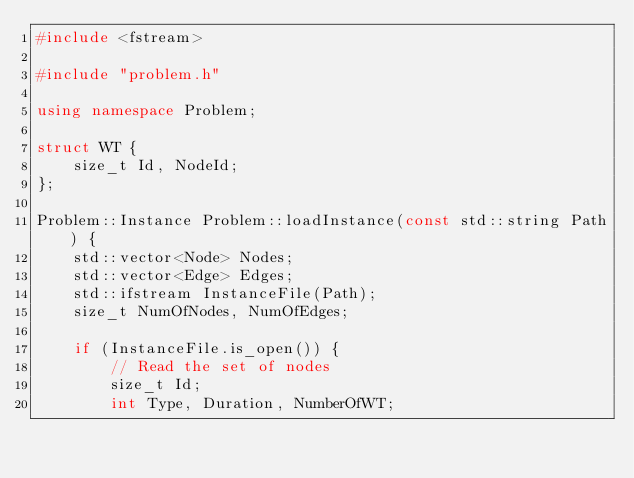<code> <loc_0><loc_0><loc_500><loc_500><_C++_>#include <fstream>

#include "problem.h"

using namespace Problem;

struct WT {
    size_t Id, NodeId;
};

Problem::Instance Problem::loadInstance(const std::string Path) {
    std::vector<Node> Nodes;
    std::vector<Edge> Edges;
    std::ifstream InstanceFile(Path);
    size_t NumOfNodes, NumOfEdges;

    if (InstanceFile.is_open()) {
        // Read the set of nodes
        size_t Id;
        int Type, Duration, NumberOfWT;</code> 